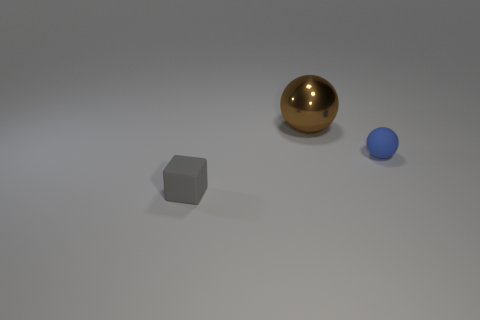The other small thing that is the same shape as the brown metal thing is what color?
Provide a succinct answer. Blue. What number of matte cubes are the same color as the big shiny object?
Your answer should be compact. 0. There is a object that is behind the tiny matte object behind the small thing that is in front of the blue thing; what color is it?
Provide a short and direct response. Brown. Do the large thing and the cube have the same material?
Offer a terse response. No. Do the big metal object and the blue object have the same shape?
Your response must be concise. Yes. Is the number of tiny rubber objects that are to the right of the matte sphere the same as the number of small gray matte things in front of the brown object?
Provide a short and direct response. No. What is the color of the thing that is made of the same material as the cube?
Keep it short and to the point. Blue. How many tiny blue spheres have the same material as the gray object?
Provide a short and direct response. 1. How many tiny objects are the same shape as the large brown metal thing?
Ensure brevity in your answer.  1. Is the number of big metal spheres on the right side of the blue object the same as the number of big gray metal spheres?
Make the answer very short. Yes. 